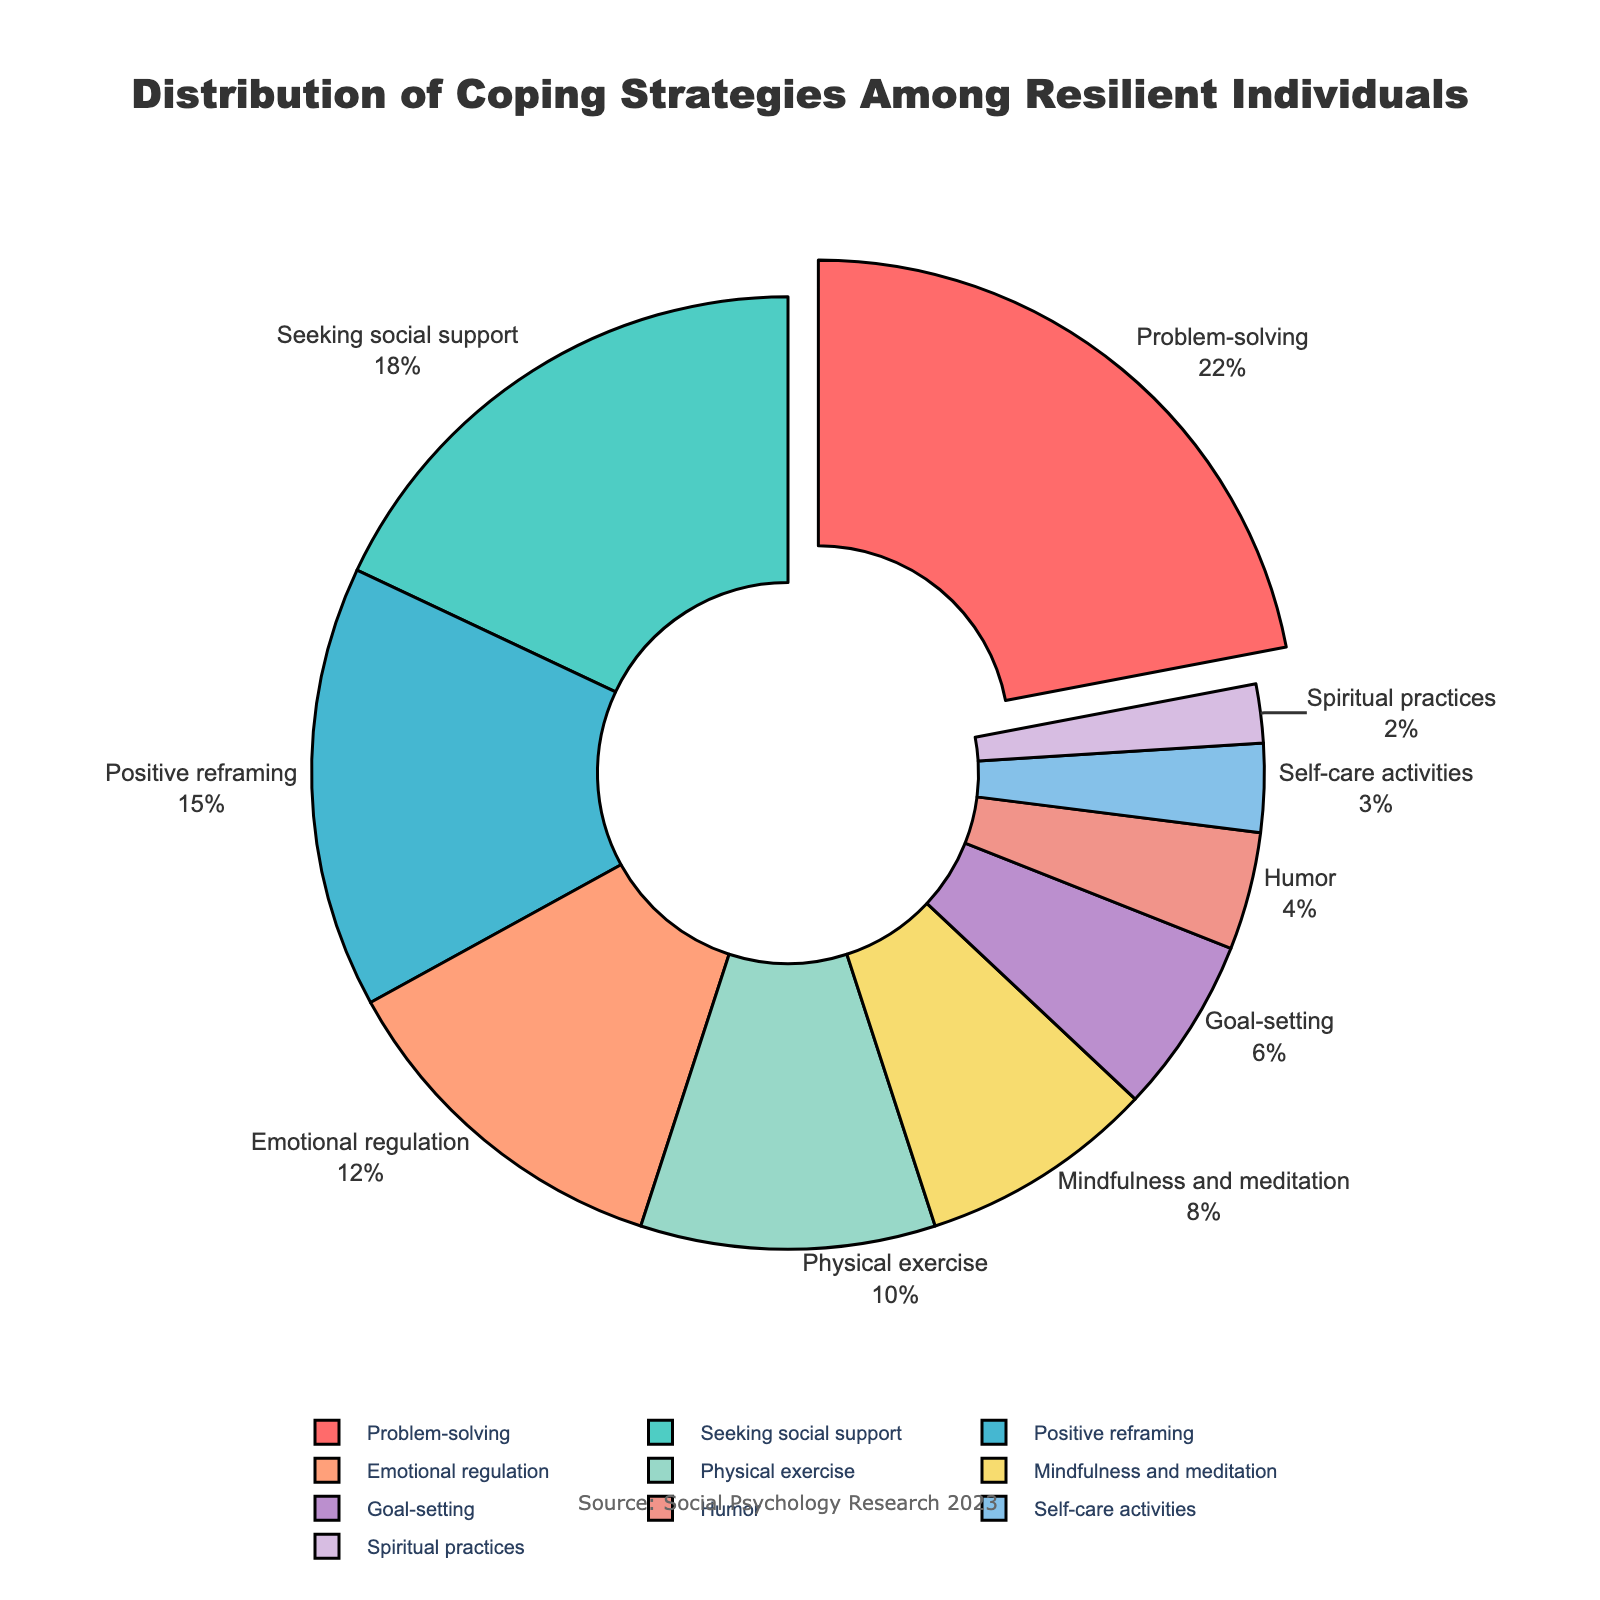What's the most common coping strategy among resilient individuals? The most common coping strategy is the one with the highest percentage slice in the pie chart. Here, "Problem-solving" has the largest slice, pulled out slightly from the pie for emphasis.
Answer: Problem-solving Which two coping strategies have the smallest percentage? The two coping strategies with the smallest slices in the pie chart are "Spiritual practices" and "Self-care activities" with 2% and 3%, respectively.
Answer: Spiritual practices and Self-care activities How much more common is Problem-solving compared to Humor? Firstly, note the percentages: Problem-solving is 22% and Humor is 4%. Subtract 4 from 22 to find the difference.
Answer: 18% What percentage of individuals use strategies related to mindfulness, spirituality, or self-care? Add the percentages for these strategies: Mindfulness and meditation (8%), Spiritual practices (2%), and Self-care activities (3%). The total is 8 + 2 + 3 = 13%.
Answer: 13% Are Emotional regulation and Physical exercise equally common? Compare the percentages of both: Emotional regulation is 12% and Physical exercise is 10%. They are not equal.
Answer: No Which coping strategy has a slightly smaller percentage than Positive reframing? Positive reframing is 15%, and the slightly smaller category is Emotional regulation at 12%.
Answer: Emotional regulation How much greater is the percentage for Seeking social support than for Goal-setting? Compare the percentages: Seeking social support is 18% and Goal-setting is 6%. Subtract 6 from 18 to find the difference.
Answer: 12% What's the combined percentage of Problem-solving and Seeking social support? Sum the percentages: Problem-solving (22%) and Seeking social support (18%). The total is 22 + 18 = 40%.
Answer: 40% Are Positive reframing and Emotional regulation together more common than Physical exercise and Mindfulness and meditation together? Add the percentages for both sets: Positive reframing (15%) + Emotional regulation (12%) = 27%, and Physical exercise (10%) + Mindfulness and meditation (8%) = 18%. Compare the sums.
Answer: Yes What is the difference between the highest and the second-highest percentages? Identify the two highest percentage categories: Problem-solving (22%) and Seeking social support (18%). Subtract 18 from 22.
Answer: 4% 